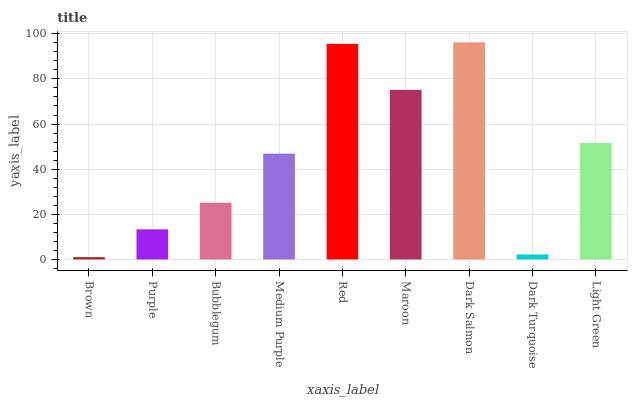Is Brown the minimum?
Answer yes or no. Yes. Is Dark Salmon the maximum?
Answer yes or no. Yes. Is Purple the minimum?
Answer yes or no. No. Is Purple the maximum?
Answer yes or no. No. Is Purple greater than Brown?
Answer yes or no. Yes. Is Brown less than Purple?
Answer yes or no. Yes. Is Brown greater than Purple?
Answer yes or no. No. Is Purple less than Brown?
Answer yes or no. No. Is Medium Purple the high median?
Answer yes or no. Yes. Is Medium Purple the low median?
Answer yes or no. Yes. Is Red the high median?
Answer yes or no. No. Is Dark Salmon the low median?
Answer yes or no. No. 